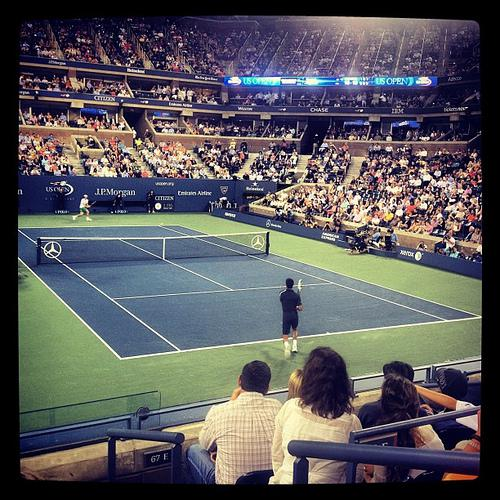Question: where was the photo taken?
Choices:
A. Mount Everest.
B. Matterhorn.
C. Hawaii.
D. Tennis court.
Answer with the letter. Answer: D Question: what game is being played?
Choices:
A. Tennis.
B. Baseball.
C. Soccer.
D. Handball.
Answer with the letter. Answer: A Question: who is the sponsor?
Choices:
A. Audi.
B. Cadillac.
C. Mercedes.
D. Time Warner.
Answer with the letter. Answer: C Question: when was the photo taken?
Choices:
A. Daytime.
B. Evening.
C. Night.
D. Morning.
Answer with the letter. Answer: C 